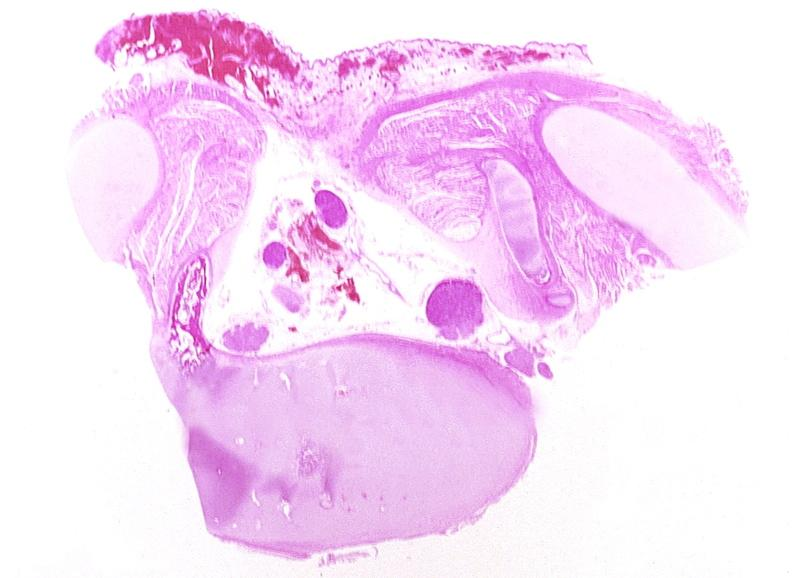does this image show neural tube defect, meningomyelocele?
Answer the question using a single word or phrase. Yes 